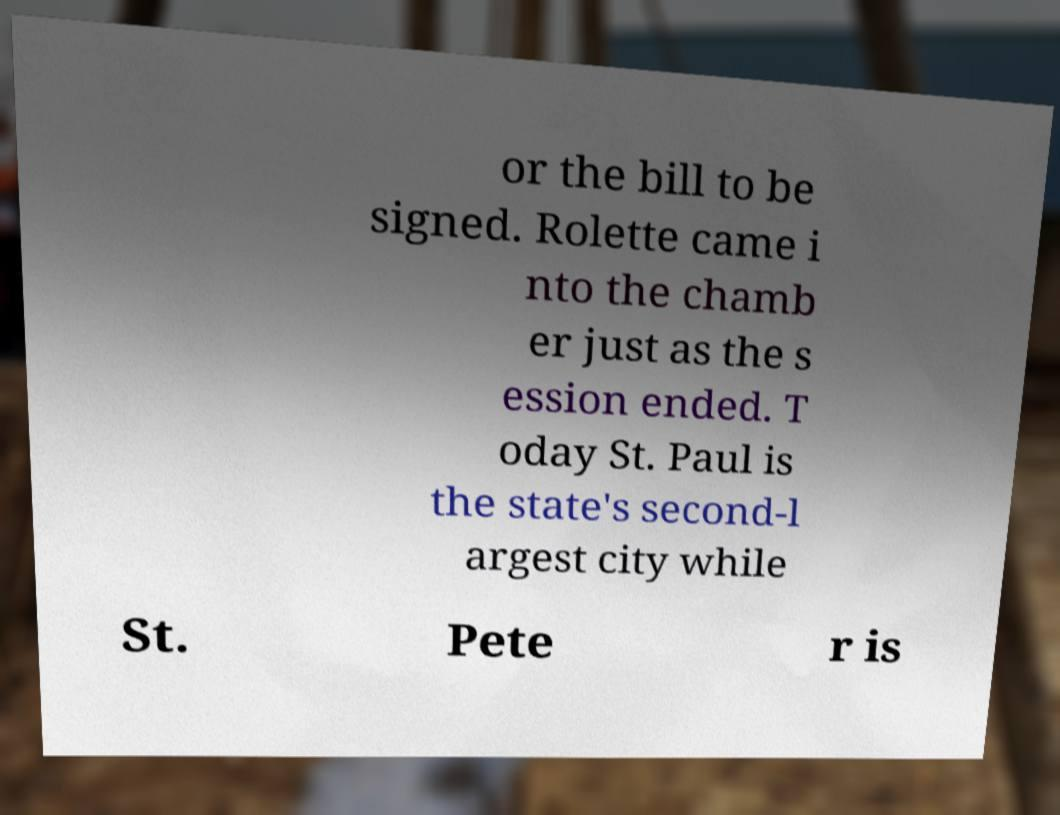Can you accurately transcribe the text from the provided image for me? or the bill to be signed. Rolette came i nto the chamb er just as the s ession ended. T oday St. Paul is the state's second-l argest city while St. Pete r is 